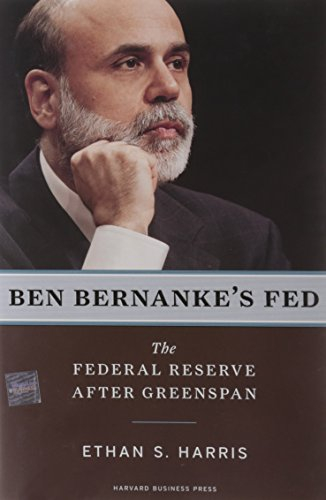What type of book is this? This is a non-fiction book focusing on the realm of economic policy and central banking, particularly examining the Federal Reserve under the stewardship of Ben Bernanke. 